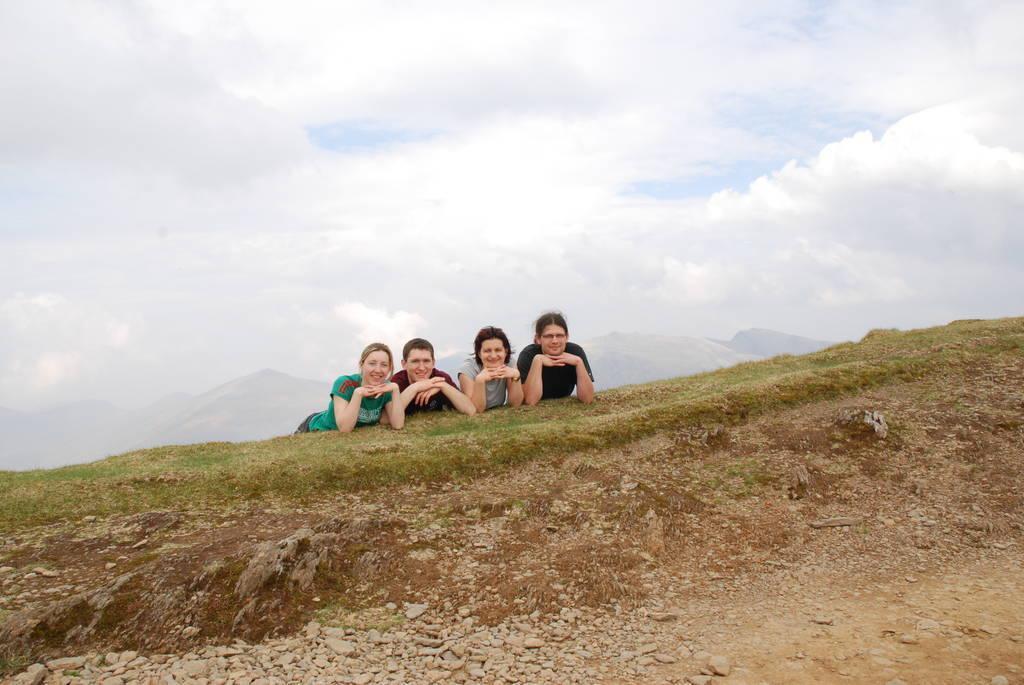Please provide a concise description of this image. In this image I can see four persons, the person at left wearing green shirt and the person at right wearing black shirt. Background the sky is in white and blue color. 